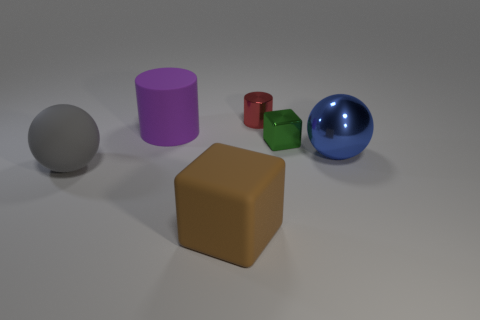Add 4 big blue shiny objects. How many objects exist? 10 Subtract all cylinders. How many objects are left? 4 Subtract 1 blocks. How many blocks are left? 1 Subtract all brown cylinders. How many red blocks are left? 0 Subtract all large blue matte cubes. Subtract all green metallic cubes. How many objects are left? 5 Add 6 large rubber blocks. How many large rubber blocks are left? 7 Add 4 tiny things. How many tiny things exist? 6 Subtract all brown cubes. How many cubes are left? 1 Subtract 1 blue spheres. How many objects are left? 5 Subtract all cyan cubes. Subtract all green balls. How many cubes are left? 2 